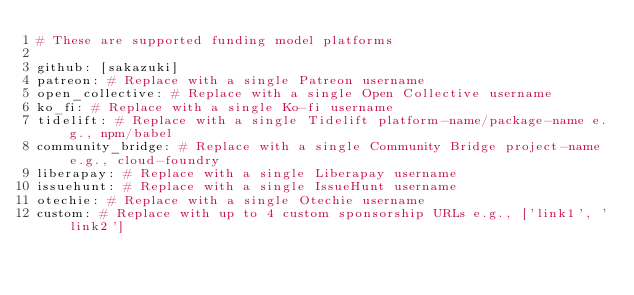<code> <loc_0><loc_0><loc_500><loc_500><_YAML_># These are supported funding model platforms

github: [sakazuki]
patreon: # Replace with a single Patreon username
open_collective: # Replace with a single Open Collective username
ko_fi: # Replace with a single Ko-fi username
tidelift: # Replace with a single Tidelift platform-name/package-name e.g., npm/babel
community_bridge: # Replace with a single Community Bridge project-name e.g., cloud-foundry
liberapay: # Replace with a single Liberapay username
issuehunt: # Replace with a single IssueHunt username
otechie: # Replace with a single Otechie username
custom: # Replace with up to 4 custom sponsorship URLs e.g., ['link1', 'link2']
</code> 